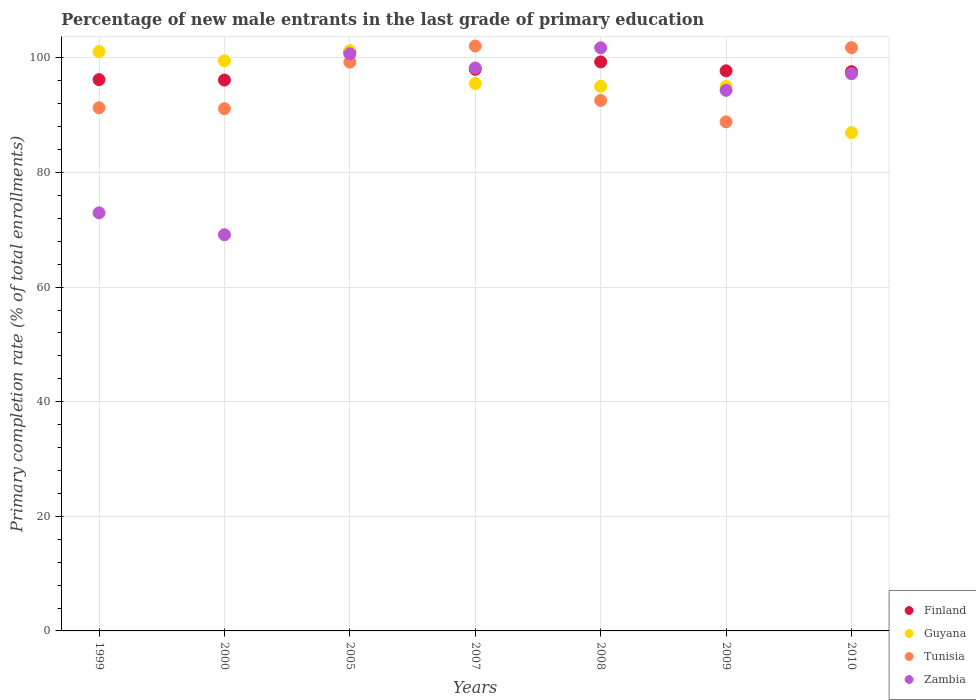How many different coloured dotlines are there?
Offer a terse response. 4. Is the number of dotlines equal to the number of legend labels?
Ensure brevity in your answer.  Yes. What is the percentage of new male entrants in Tunisia in 2009?
Your answer should be very brief. 88.84. Across all years, what is the maximum percentage of new male entrants in Guyana?
Your response must be concise. 101.26. Across all years, what is the minimum percentage of new male entrants in Tunisia?
Offer a very short reply. 88.84. In which year was the percentage of new male entrants in Finland minimum?
Your response must be concise. 2000. What is the total percentage of new male entrants in Finland in the graph?
Give a very brief answer. 686.06. What is the difference between the percentage of new male entrants in Guyana in 2007 and that in 2009?
Your response must be concise. 0.51. What is the difference between the percentage of new male entrants in Guyana in 2009 and the percentage of new male entrants in Zambia in 2010?
Ensure brevity in your answer.  -2.21. What is the average percentage of new male entrants in Zambia per year?
Give a very brief answer. 90.63. In the year 2009, what is the difference between the percentage of new male entrants in Zambia and percentage of new male entrants in Guyana?
Provide a succinct answer. -0.68. What is the ratio of the percentage of new male entrants in Finland in 2005 to that in 2007?
Your response must be concise. 1.03. What is the difference between the highest and the second highest percentage of new male entrants in Guyana?
Offer a very short reply. 0.16. What is the difference between the highest and the lowest percentage of new male entrants in Guyana?
Ensure brevity in your answer.  14.32. Is the sum of the percentage of new male entrants in Zambia in 2007 and 2008 greater than the maximum percentage of new male entrants in Finland across all years?
Provide a short and direct response. Yes. Is it the case that in every year, the sum of the percentage of new male entrants in Zambia and percentage of new male entrants in Guyana  is greater than the percentage of new male entrants in Tunisia?
Offer a very short reply. Yes. Does the percentage of new male entrants in Finland monotonically increase over the years?
Your answer should be very brief. No. Is the percentage of new male entrants in Finland strictly less than the percentage of new male entrants in Zambia over the years?
Give a very brief answer. No. How many dotlines are there?
Make the answer very short. 4. Does the graph contain any zero values?
Provide a succinct answer. No. Where does the legend appear in the graph?
Ensure brevity in your answer.  Bottom right. How are the legend labels stacked?
Offer a very short reply. Vertical. What is the title of the graph?
Ensure brevity in your answer.  Percentage of new male entrants in the last grade of primary education. What is the label or title of the Y-axis?
Offer a very short reply. Primary completion rate (% of total enrollments). What is the Primary completion rate (% of total enrollments) in Finland in 1999?
Ensure brevity in your answer.  96.22. What is the Primary completion rate (% of total enrollments) of Guyana in 1999?
Ensure brevity in your answer.  101.1. What is the Primary completion rate (% of total enrollments) of Tunisia in 1999?
Keep it short and to the point. 91.3. What is the Primary completion rate (% of total enrollments) of Zambia in 1999?
Give a very brief answer. 72.97. What is the Primary completion rate (% of total enrollments) of Finland in 2000?
Offer a terse response. 96.14. What is the Primary completion rate (% of total enrollments) of Guyana in 2000?
Ensure brevity in your answer.  99.5. What is the Primary completion rate (% of total enrollments) in Tunisia in 2000?
Provide a short and direct response. 91.14. What is the Primary completion rate (% of total enrollments) in Zambia in 2000?
Your answer should be very brief. 69.14. What is the Primary completion rate (% of total enrollments) in Finland in 2005?
Make the answer very short. 101.02. What is the Primary completion rate (% of total enrollments) in Guyana in 2005?
Your answer should be compact. 101.26. What is the Primary completion rate (% of total enrollments) in Tunisia in 2005?
Give a very brief answer. 99.27. What is the Primary completion rate (% of total enrollments) in Zambia in 2005?
Offer a very short reply. 100.72. What is the Primary completion rate (% of total enrollments) in Finland in 2007?
Make the answer very short. 98.02. What is the Primary completion rate (% of total enrollments) in Guyana in 2007?
Provide a short and direct response. 95.54. What is the Primary completion rate (% of total enrollments) in Tunisia in 2007?
Offer a very short reply. 102.08. What is the Primary completion rate (% of total enrollments) of Zambia in 2007?
Give a very brief answer. 98.25. What is the Primary completion rate (% of total enrollments) in Finland in 2008?
Keep it short and to the point. 99.31. What is the Primary completion rate (% of total enrollments) in Guyana in 2008?
Provide a succinct answer. 95.04. What is the Primary completion rate (% of total enrollments) in Tunisia in 2008?
Your answer should be very brief. 92.57. What is the Primary completion rate (% of total enrollments) of Zambia in 2008?
Make the answer very short. 101.77. What is the Primary completion rate (% of total enrollments) of Finland in 2009?
Your answer should be very brief. 97.75. What is the Primary completion rate (% of total enrollments) of Guyana in 2009?
Your answer should be compact. 95.03. What is the Primary completion rate (% of total enrollments) in Tunisia in 2009?
Provide a short and direct response. 88.84. What is the Primary completion rate (% of total enrollments) in Zambia in 2009?
Your response must be concise. 94.35. What is the Primary completion rate (% of total enrollments) in Finland in 2010?
Provide a short and direct response. 97.61. What is the Primary completion rate (% of total enrollments) of Guyana in 2010?
Give a very brief answer. 86.94. What is the Primary completion rate (% of total enrollments) in Tunisia in 2010?
Your answer should be compact. 101.79. What is the Primary completion rate (% of total enrollments) in Zambia in 2010?
Make the answer very short. 97.24. Across all years, what is the maximum Primary completion rate (% of total enrollments) of Finland?
Ensure brevity in your answer.  101.02. Across all years, what is the maximum Primary completion rate (% of total enrollments) of Guyana?
Make the answer very short. 101.26. Across all years, what is the maximum Primary completion rate (% of total enrollments) of Tunisia?
Offer a very short reply. 102.08. Across all years, what is the maximum Primary completion rate (% of total enrollments) of Zambia?
Give a very brief answer. 101.77. Across all years, what is the minimum Primary completion rate (% of total enrollments) of Finland?
Your response must be concise. 96.14. Across all years, what is the minimum Primary completion rate (% of total enrollments) in Guyana?
Ensure brevity in your answer.  86.94. Across all years, what is the minimum Primary completion rate (% of total enrollments) in Tunisia?
Keep it short and to the point. 88.84. Across all years, what is the minimum Primary completion rate (% of total enrollments) in Zambia?
Offer a very short reply. 69.14. What is the total Primary completion rate (% of total enrollments) of Finland in the graph?
Give a very brief answer. 686.06. What is the total Primary completion rate (% of total enrollments) of Guyana in the graph?
Provide a short and direct response. 674.42. What is the total Primary completion rate (% of total enrollments) of Tunisia in the graph?
Keep it short and to the point. 667. What is the total Primary completion rate (% of total enrollments) in Zambia in the graph?
Make the answer very short. 634.44. What is the difference between the Primary completion rate (% of total enrollments) in Finland in 1999 and that in 2000?
Make the answer very short. 0.07. What is the difference between the Primary completion rate (% of total enrollments) in Guyana in 1999 and that in 2000?
Your answer should be compact. 1.6. What is the difference between the Primary completion rate (% of total enrollments) of Tunisia in 1999 and that in 2000?
Make the answer very short. 0.16. What is the difference between the Primary completion rate (% of total enrollments) in Zambia in 1999 and that in 2000?
Your response must be concise. 3.82. What is the difference between the Primary completion rate (% of total enrollments) of Finland in 1999 and that in 2005?
Your answer should be very brief. -4.8. What is the difference between the Primary completion rate (% of total enrollments) of Guyana in 1999 and that in 2005?
Offer a very short reply. -0.16. What is the difference between the Primary completion rate (% of total enrollments) of Tunisia in 1999 and that in 2005?
Provide a short and direct response. -7.96. What is the difference between the Primary completion rate (% of total enrollments) of Zambia in 1999 and that in 2005?
Give a very brief answer. -27.76. What is the difference between the Primary completion rate (% of total enrollments) in Finland in 1999 and that in 2007?
Provide a short and direct response. -1.8. What is the difference between the Primary completion rate (% of total enrollments) in Guyana in 1999 and that in 2007?
Offer a terse response. 5.56. What is the difference between the Primary completion rate (% of total enrollments) in Tunisia in 1999 and that in 2007?
Provide a succinct answer. -10.78. What is the difference between the Primary completion rate (% of total enrollments) of Zambia in 1999 and that in 2007?
Offer a very short reply. -25.29. What is the difference between the Primary completion rate (% of total enrollments) of Finland in 1999 and that in 2008?
Offer a terse response. -3.09. What is the difference between the Primary completion rate (% of total enrollments) of Guyana in 1999 and that in 2008?
Ensure brevity in your answer.  6.06. What is the difference between the Primary completion rate (% of total enrollments) of Tunisia in 1999 and that in 2008?
Keep it short and to the point. -1.27. What is the difference between the Primary completion rate (% of total enrollments) in Zambia in 1999 and that in 2008?
Provide a short and direct response. -28.8. What is the difference between the Primary completion rate (% of total enrollments) of Finland in 1999 and that in 2009?
Provide a succinct answer. -1.54. What is the difference between the Primary completion rate (% of total enrollments) in Guyana in 1999 and that in 2009?
Ensure brevity in your answer.  6.07. What is the difference between the Primary completion rate (% of total enrollments) in Tunisia in 1999 and that in 2009?
Provide a succinct answer. 2.46. What is the difference between the Primary completion rate (% of total enrollments) of Zambia in 1999 and that in 2009?
Ensure brevity in your answer.  -21.38. What is the difference between the Primary completion rate (% of total enrollments) of Finland in 1999 and that in 2010?
Provide a succinct answer. -1.39. What is the difference between the Primary completion rate (% of total enrollments) of Guyana in 1999 and that in 2010?
Keep it short and to the point. 14.16. What is the difference between the Primary completion rate (% of total enrollments) in Tunisia in 1999 and that in 2010?
Offer a very short reply. -10.49. What is the difference between the Primary completion rate (% of total enrollments) of Zambia in 1999 and that in 2010?
Your response must be concise. -24.27. What is the difference between the Primary completion rate (% of total enrollments) in Finland in 2000 and that in 2005?
Your response must be concise. -4.88. What is the difference between the Primary completion rate (% of total enrollments) in Guyana in 2000 and that in 2005?
Offer a very short reply. -1.76. What is the difference between the Primary completion rate (% of total enrollments) of Tunisia in 2000 and that in 2005?
Make the answer very short. -8.13. What is the difference between the Primary completion rate (% of total enrollments) of Zambia in 2000 and that in 2005?
Keep it short and to the point. -31.58. What is the difference between the Primary completion rate (% of total enrollments) of Finland in 2000 and that in 2007?
Make the answer very short. -1.88. What is the difference between the Primary completion rate (% of total enrollments) of Guyana in 2000 and that in 2007?
Offer a very short reply. 3.96. What is the difference between the Primary completion rate (% of total enrollments) in Tunisia in 2000 and that in 2007?
Your response must be concise. -10.94. What is the difference between the Primary completion rate (% of total enrollments) in Zambia in 2000 and that in 2007?
Your answer should be compact. -29.11. What is the difference between the Primary completion rate (% of total enrollments) in Finland in 2000 and that in 2008?
Give a very brief answer. -3.16. What is the difference between the Primary completion rate (% of total enrollments) of Guyana in 2000 and that in 2008?
Offer a very short reply. 4.46. What is the difference between the Primary completion rate (% of total enrollments) of Tunisia in 2000 and that in 2008?
Provide a short and direct response. -1.43. What is the difference between the Primary completion rate (% of total enrollments) of Zambia in 2000 and that in 2008?
Make the answer very short. -32.63. What is the difference between the Primary completion rate (% of total enrollments) in Finland in 2000 and that in 2009?
Give a very brief answer. -1.61. What is the difference between the Primary completion rate (% of total enrollments) of Guyana in 2000 and that in 2009?
Your response must be concise. 4.47. What is the difference between the Primary completion rate (% of total enrollments) in Tunisia in 2000 and that in 2009?
Offer a very short reply. 2.29. What is the difference between the Primary completion rate (% of total enrollments) of Zambia in 2000 and that in 2009?
Offer a terse response. -25.21. What is the difference between the Primary completion rate (% of total enrollments) of Finland in 2000 and that in 2010?
Provide a succinct answer. -1.47. What is the difference between the Primary completion rate (% of total enrollments) of Guyana in 2000 and that in 2010?
Keep it short and to the point. 12.55. What is the difference between the Primary completion rate (% of total enrollments) of Tunisia in 2000 and that in 2010?
Make the answer very short. -10.65. What is the difference between the Primary completion rate (% of total enrollments) of Zambia in 2000 and that in 2010?
Your response must be concise. -28.1. What is the difference between the Primary completion rate (% of total enrollments) in Finland in 2005 and that in 2007?
Make the answer very short. 3. What is the difference between the Primary completion rate (% of total enrollments) in Guyana in 2005 and that in 2007?
Keep it short and to the point. 5.72. What is the difference between the Primary completion rate (% of total enrollments) of Tunisia in 2005 and that in 2007?
Your response must be concise. -2.82. What is the difference between the Primary completion rate (% of total enrollments) of Zambia in 2005 and that in 2007?
Offer a terse response. 2.47. What is the difference between the Primary completion rate (% of total enrollments) in Finland in 2005 and that in 2008?
Your response must be concise. 1.71. What is the difference between the Primary completion rate (% of total enrollments) in Guyana in 2005 and that in 2008?
Provide a short and direct response. 6.22. What is the difference between the Primary completion rate (% of total enrollments) of Tunisia in 2005 and that in 2008?
Offer a terse response. 6.69. What is the difference between the Primary completion rate (% of total enrollments) of Zambia in 2005 and that in 2008?
Your answer should be compact. -1.05. What is the difference between the Primary completion rate (% of total enrollments) in Finland in 2005 and that in 2009?
Give a very brief answer. 3.26. What is the difference between the Primary completion rate (% of total enrollments) in Guyana in 2005 and that in 2009?
Your answer should be compact. 6.23. What is the difference between the Primary completion rate (% of total enrollments) of Tunisia in 2005 and that in 2009?
Give a very brief answer. 10.42. What is the difference between the Primary completion rate (% of total enrollments) in Zambia in 2005 and that in 2009?
Offer a terse response. 6.38. What is the difference between the Primary completion rate (% of total enrollments) of Finland in 2005 and that in 2010?
Your answer should be very brief. 3.41. What is the difference between the Primary completion rate (% of total enrollments) in Guyana in 2005 and that in 2010?
Give a very brief answer. 14.32. What is the difference between the Primary completion rate (% of total enrollments) of Tunisia in 2005 and that in 2010?
Give a very brief answer. -2.52. What is the difference between the Primary completion rate (% of total enrollments) of Zambia in 2005 and that in 2010?
Make the answer very short. 3.48. What is the difference between the Primary completion rate (% of total enrollments) of Finland in 2007 and that in 2008?
Offer a terse response. -1.29. What is the difference between the Primary completion rate (% of total enrollments) in Guyana in 2007 and that in 2008?
Provide a succinct answer. 0.5. What is the difference between the Primary completion rate (% of total enrollments) in Tunisia in 2007 and that in 2008?
Offer a terse response. 9.51. What is the difference between the Primary completion rate (% of total enrollments) of Zambia in 2007 and that in 2008?
Provide a short and direct response. -3.52. What is the difference between the Primary completion rate (% of total enrollments) of Finland in 2007 and that in 2009?
Offer a terse response. 0.26. What is the difference between the Primary completion rate (% of total enrollments) in Guyana in 2007 and that in 2009?
Provide a short and direct response. 0.51. What is the difference between the Primary completion rate (% of total enrollments) of Tunisia in 2007 and that in 2009?
Provide a succinct answer. 13.24. What is the difference between the Primary completion rate (% of total enrollments) in Zambia in 2007 and that in 2009?
Make the answer very short. 3.91. What is the difference between the Primary completion rate (% of total enrollments) in Finland in 2007 and that in 2010?
Provide a short and direct response. 0.41. What is the difference between the Primary completion rate (% of total enrollments) of Guyana in 2007 and that in 2010?
Your answer should be very brief. 8.59. What is the difference between the Primary completion rate (% of total enrollments) in Tunisia in 2007 and that in 2010?
Provide a short and direct response. 0.29. What is the difference between the Primary completion rate (% of total enrollments) in Zambia in 2007 and that in 2010?
Your answer should be very brief. 1.01. What is the difference between the Primary completion rate (% of total enrollments) of Finland in 2008 and that in 2009?
Give a very brief answer. 1.55. What is the difference between the Primary completion rate (% of total enrollments) in Guyana in 2008 and that in 2009?
Ensure brevity in your answer.  0.01. What is the difference between the Primary completion rate (% of total enrollments) in Tunisia in 2008 and that in 2009?
Offer a terse response. 3.73. What is the difference between the Primary completion rate (% of total enrollments) in Zambia in 2008 and that in 2009?
Make the answer very short. 7.42. What is the difference between the Primary completion rate (% of total enrollments) in Finland in 2008 and that in 2010?
Provide a succinct answer. 1.7. What is the difference between the Primary completion rate (% of total enrollments) of Guyana in 2008 and that in 2010?
Your response must be concise. 8.1. What is the difference between the Primary completion rate (% of total enrollments) in Tunisia in 2008 and that in 2010?
Your answer should be compact. -9.22. What is the difference between the Primary completion rate (% of total enrollments) in Zambia in 2008 and that in 2010?
Offer a terse response. 4.53. What is the difference between the Primary completion rate (% of total enrollments) in Finland in 2009 and that in 2010?
Provide a short and direct response. 0.14. What is the difference between the Primary completion rate (% of total enrollments) in Guyana in 2009 and that in 2010?
Ensure brevity in your answer.  8.09. What is the difference between the Primary completion rate (% of total enrollments) in Tunisia in 2009 and that in 2010?
Your response must be concise. -12.95. What is the difference between the Primary completion rate (% of total enrollments) of Zambia in 2009 and that in 2010?
Provide a succinct answer. -2.89. What is the difference between the Primary completion rate (% of total enrollments) in Finland in 1999 and the Primary completion rate (% of total enrollments) in Guyana in 2000?
Offer a terse response. -3.28. What is the difference between the Primary completion rate (% of total enrollments) in Finland in 1999 and the Primary completion rate (% of total enrollments) in Tunisia in 2000?
Your response must be concise. 5.08. What is the difference between the Primary completion rate (% of total enrollments) of Finland in 1999 and the Primary completion rate (% of total enrollments) of Zambia in 2000?
Provide a succinct answer. 27.07. What is the difference between the Primary completion rate (% of total enrollments) in Guyana in 1999 and the Primary completion rate (% of total enrollments) in Tunisia in 2000?
Your response must be concise. 9.96. What is the difference between the Primary completion rate (% of total enrollments) in Guyana in 1999 and the Primary completion rate (% of total enrollments) in Zambia in 2000?
Keep it short and to the point. 31.96. What is the difference between the Primary completion rate (% of total enrollments) in Tunisia in 1999 and the Primary completion rate (% of total enrollments) in Zambia in 2000?
Your answer should be compact. 22.16. What is the difference between the Primary completion rate (% of total enrollments) of Finland in 1999 and the Primary completion rate (% of total enrollments) of Guyana in 2005?
Your answer should be compact. -5.05. What is the difference between the Primary completion rate (% of total enrollments) in Finland in 1999 and the Primary completion rate (% of total enrollments) in Tunisia in 2005?
Keep it short and to the point. -3.05. What is the difference between the Primary completion rate (% of total enrollments) of Finland in 1999 and the Primary completion rate (% of total enrollments) of Zambia in 2005?
Your answer should be very brief. -4.51. What is the difference between the Primary completion rate (% of total enrollments) of Guyana in 1999 and the Primary completion rate (% of total enrollments) of Tunisia in 2005?
Provide a succinct answer. 1.84. What is the difference between the Primary completion rate (% of total enrollments) of Guyana in 1999 and the Primary completion rate (% of total enrollments) of Zambia in 2005?
Offer a very short reply. 0.38. What is the difference between the Primary completion rate (% of total enrollments) in Tunisia in 1999 and the Primary completion rate (% of total enrollments) in Zambia in 2005?
Make the answer very short. -9.42. What is the difference between the Primary completion rate (% of total enrollments) in Finland in 1999 and the Primary completion rate (% of total enrollments) in Guyana in 2007?
Your response must be concise. 0.68. What is the difference between the Primary completion rate (% of total enrollments) of Finland in 1999 and the Primary completion rate (% of total enrollments) of Tunisia in 2007?
Keep it short and to the point. -5.87. What is the difference between the Primary completion rate (% of total enrollments) in Finland in 1999 and the Primary completion rate (% of total enrollments) in Zambia in 2007?
Your answer should be compact. -2.04. What is the difference between the Primary completion rate (% of total enrollments) of Guyana in 1999 and the Primary completion rate (% of total enrollments) of Tunisia in 2007?
Your answer should be very brief. -0.98. What is the difference between the Primary completion rate (% of total enrollments) in Guyana in 1999 and the Primary completion rate (% of total enrollments) in Zambia in 2007?
Keep it short and to the point. 2.85. What is the difference between the Primary completion rate (% of total enrollments) of Tunisia in 1999 and the Primary completion rate (% of total enrollments) of Zambia in 2007?
Your response must be concise. -6.95. What is the difference between the Primary completion rate (% of total enrollments) in Finland in 1999 and the Primary completion rate (% of total enrollments) in Guyana in 2008?
Offer a very short reply. 1.18. What is the difference between the Primary completion rate (% of total enrollments) of Finland in 1999 and the Primary completion rate (% of total enrollments) of Tunisia in 2008?
Your answer should be very brief. 3.64. What is the difference between the Primary completion rate (% of total enrollments) in Finland in 1999 and the Primary completion rate (% of total enrollments) in Zambia in 2008?
Your answer should be very brief. -5.55. What is the difference between the Primary completion rate (% of total enrollments) in Guyana in 1999 and the Primary completion rate (% of total enrollments) in Tunisia in 2008?
Provide a short and direct response. 8.53. What is the difference between the Primary completion rate (% of total enrollments) of Guyana in 1999 and the Primary completion rate (% of total enrollments) of Zambia in 2008?
Your response must be concise. -0.67. What is the difference between the Primary completion rate (% of total enrollments) of Tunisia in 1999 and the Primary completion rate (% of total enrollments) of Zambia in 2008?
Provide a short and direct response. -10.47. What is the difference between the Primary completion rate (% of total enrollments) in Finland in 1999 and the Primary completion rate (% of total enrollments) in Guyana in 2009?
Make the answer very short. 1.18. What is the difference between the Primary completion rate (% of total enrollments) in Finland in 1999 and the Primary completion rate (% of total enrollments) in Tunisia in 2009?
Your answer should be compact. 7.37. What is the difference between the Primary completion rate (% of total enrollments) in Finland in 1999 and the Primary completion rate (% of total enrollments) in Zambia in 2009?
Your response must be concise. 1.87. What is the difference between the Primary completion rate (% of total enrollments) in Guyana in 1999 and the Primary completion rate (% of total enrollments) in Tunisia in 2009?
Offer a very short reply. 12.26. What is the difference between the Primary completion rate (% of total enrollments) in Guyana in 1999 and the Primary completion rate (% of total enrollments) in Zambia in 2009?
Ensure brevity in your answer.  6.75. What is the difference between the Primary completion rate (% of total enrollments) of Tunisia in 1999 and the Primary completion rate (% of total enrollments) of Zambia in 2009?
Provide a short and direct response. -3.05. What is the difference between the Primary completion rate (% of total enrollments) of Finland in 1999 and the Primary completion rate (% of total enrollments) of Guyana in 2010?
Offer a very short reply. 9.27. What is the difference between the Primary completion rate (% of total enrollments) in Finland in 1999 and the Primary completion rate (% of total enrollments) in Tunisia in 2010?
Keep it short and to the point. -5.58. What is the difference between the Primary completion rate (% of total enrollments) in Finland in 1999 and the Primary completion rate (% of total enrollments) in Zambia in 2010?
Your response must be concise. -1.02. What is the difference between the Primary completion rate (% of total enrollments) of Guyana in 1999 and the Primary completion rate (% of total enrollments) of Tunisia in 2010?
Keep it short and to the point. -0.69. What is the difference between the Primary completion rate (% of total enrollments) of Guyana in 1999 and the Primary completion rate (% of total enrollments) of Zambia in 2010?
Give a very brief answer. 3.86. What is the difference between the Primary completion rate (% of total enrollments) in Tunisia in 1999 and the Primary completion rate (% of total enrollments) in Zambia in 2010?
Provide a succinct answer. -5.94. What is the difference between the Primary completion rate (% of total enrollments) of Finland in 2000 and the Primary completion rate (% of total enrollments) of Guyana in 2005?
Offer a terse response. -5.12. What is the difference between the Primary completion rate (% of total enrollments) of Finland in 2000 and the Primary completion rate (% of total enrollments) of Tunisia in 2005?
Your answer should be compact. -3.13. What is the difference between the Primary completion rate (% of total enrollments) of Finland in 2000 and the Primary completion rate (% of total enrollments) of Zambia in 2005?
Offer a terse response. -4.58. What is the difference between the Primary completion rate (% of total enrollments) of Guyana in 2000 and the Primary completion rate (% of total enrollments) of Tunisia in 2005?
Your response must be concise. 0.23. What is the difference between the Primary completion rate (% of total enrollments) of Guyana in 2000 and the Primary completion rate (% of total enrollments) of Zambia in 2005?
Your answer should be very brief. -1.23. What is the difference between the Primary completion rate (% of total enrollments) of Tunisia in 2000 and the Primary completion rate (% of total enrollments) of Zambia in 2005?
Provide a succinct answer. -9.58. What is the difference between the Primary completion rate (% of total enrollments) in Finland in 2000 and the Primary completion rate (% of total enrollments) in Guyana in 2007?
Make the answer very short. 0.6. What is the difference between the Primary completion rate (% of total enrollments) of Finland in 2000 and the Primary completion rate (% of total enrollments) of Tunisia in 2007?
Your answer should be compact. -5.94. What is the difference between the Primary completion rate (% of total enrollments) in Finland in 2000 and the Primary completion rate (% of total enrollments) in Zambia in 2007?
Give a very brief answer. -2.11. What is the difference between the Primary completion rate (% of total enrollments) in Guyana in 2000 and the Primary completion rate (% of total enrollments) in Tunisia in 2007?
Your response must be concise. -2.58. What is the difference between the Primary completion rate (% of total enrollments) in Guyana in 2000 and the Primary completion rate (% of total enrollments) in Zambia in 2007?
Provide a succinct answer. 1.24. What is the difference between the Primary completion rate (% of total enrollments) in Tunisia in 2000 and the Primary completion rate (% of total enrollments) in Zambia in 2007?
Give a very brief answer. -7.11. What is the difference between the Primary completion rate (% of total enrollments) in Finland in 2000 and the Primary completion rate (% of total enrollments) in Guyana in 2008?
Give a very brief answer. 1.1. What is the difference between the Primary completion rate (% of total enrollments) of Finland in 2000 and the Primary completion rate (% of total enrollments) of Tunisia in 2008?
Provide a short and direct response. 3.57. What is the difference between the Primary completion rate (% of total enrollments) of Finland in 2000 and the Primary completion rate (% of total enrollments) of Zambia in 2008?
Provide a short and direct response. -5.63. What is the difference between the Primary completion rate (% of total enrollments) of Guyana in 2000 and the Primary completion rate (% of total enrollments) of Tunisia in 2008?
Your answer should be very brief. 6.92. What is the difference between the Primary completion rate (% of total enrollments) of Guyana in 2000 and the Primary completion rate (% of total enrollments) of Zambia in 2008?
Your answer should be very brief. -2.27. What is the difference between the Primary completion rate (% of total enrollments) in Tunisia in 2000 and the Primary completion rate (% of total enrollments) in Zambia in 2008?
Offer a terse response. -10.63. What is the difference between the Primary completion rate (% of total enrollments) of Finland in 2000 and the Primary completion rate (% of total enrollments) of Guyana in 2009?
Make the answer very short. 1.11. What is the difference between the Primary completion rate (% of total enrollments) of Finland in 2000 and the Primary completion rate (% of total enrollments) of Tunisia in 2009?
Make the answer very short. 7.3. What is the difference between the Primary completion rate (% of total enrollments) of Finland in 2000 and the Primary completion rate (% of total enrollments) of Zambia in 2009?
Make the answer very short. 1.79. What is the difference between the Primary completion rate (% of total enrollments) of Guyana in 2000 and the Primary completion rate (% of total enrollments) of Tunisia in 2009?
Offer a very short reply. 10.65. What is the difference between the Primary completion rate (% of total enrollments) of Guyana in 2000 and the Primary completion rate (% of total enrollments) of Zambia in 2009?
Keep it short and to the point. 5.15. What is the difference between the Primary completion rate (% of total enrollments) in Tunisia in 2000 and the Primary completion rate (% of total enrollments) in Zambia in 2009?
Your answer should be compact. -3.21. What is the difference between the Primary completion rate (% of total enrollments) of Finland in 2000 and the Primary completion rate (% of total enrollments) of Guyana in 2010?
Keep it short and to the point. 9.2. What is the difference between the Primary completion rate (% of total enrollments) in Finland in 2000 and the Primary completion rate (% of total enrollments) in Tunisia in 2010?
Make the answer very short. -5.65. What is the difference between the Primary completion rate (% of total enrollments) of Finland in 2000 and the Primary completion rate (% of total enrollments) of Zambia in 2010?
Keep it short and to the point. -1.1. What is the difference between the Primary completion rate (% of total enrollments) of Guyana in 2000 and the Primary completion rate (% of total enrollments) of Tunisia in 2010?
Your answer should be compact. -2.29. What is the difference between the Primary completion rate (% of total enrollments) in Guyana in 2000 and the Primary completion rate (% of total enrollments) in Zambia in 2010?
Keep it short and to the point. 2.26. What is the difference between the Primary completion rate (% of total enrollments) in Tunisia in 2000 and the Primary completion rate (% of total enrollments) in Zambia in 2010?
Offer a very short reply. -6.1. What is the difference between the Primary completion rate (% of total enrollments) of Finland in 2005 and the Primary completion rate (% of total enrollments) of Guyana in 2007?
Your answer should be compact. 5.48. What is the difference between the Primary completion rate (% of total enrollments) in Finland in 2005 and the Primary completion rate (% of total enrollments) in Tunisia in 2007?
Your answer should be very brief. -1.07. What is the difference between the Primary completion rate (% of total enrollments) in Finland in 2005 and the Primary completion rate (% of total enrollments) in Zambia in 2007?
Offer a terse response. 2.76. What is the difference between the Primary completion rate (% of total enrollments) in Guyana in 2005 and the Primary completion rate (% of total enrollments) in Tunisia in 2007?
Your answer should be very brief. -0.82. What is the difference between the Primary completion rate (% of total enrollments) of Guyana in 2005 and the Primary completion rate (% of total enrollments) of Zambia in 2007?
Offer a very short reply. 3.01. What is the difference between the Primary completion rate (% of total enrollments) of Tunisia in 2005 and the Primary completion rate (% of total enrollments) of Zambia in 2007?
Your response must be concise. 1.01. What is the difference between the Primary completion rate (% of total enrollments) of Finland in 2005 and the Primary completion rate (% of total enrollments) of Guyana in 2008?
Keep it short and to the point. 5.98. What is the difference between the Primary completion rate (% of total enrollments) in Finland in 2005 and the Primary completion rate (% of total enrollments) in Tunisia in 2008?
Offer a terse response. 8.44. What is the difference between the Primary completion rate (% of total enrollments) of Finland in 2005 and the Primary completion rate (% of total enrollments) of Zambia in 2008?
Provide a short and direct response. -0.75. What is the difference between the Primary completion rate (% of total enrollments) of Guyana in 2005 and the Primary completion rate (% of total enrollments) of Tunisia in 2008?
Your response must be concise. 8.69. What is the difference between the Primary completion rate (% of total enrollments) of Guyana in 2005 and the Primary completion rate (% of total enrollments) of Zambia in 2008?
Offer a very short reply. -0.51. What is the difference between the Primary completion rate (% of total enrollments) of Tunisia in 2005 and the Primary completion rate (% of total enrollments) of Zambia in 2008?
Keep it short and to the point. -2.5. What is the difference between the Primary completion rate (% of total enrollments) of Finland in 2005 and the Primary completion rate (% of total enrollments) of Guyana in 2009?
Offer a terse response. 5.98. What is the difference between the Primary completion rate (% of total enrollments) of Finland in 2005 and the Primary completion rate (% of total enrollments) of Tunisia in 2009?
Make the answer very short. 12.17. What is the difference between the Primary completion rate (% of total enrollments) of Finland in 2005 and the Primary completion rate (% of total enrollments) of Zambia in 2009?
Your answer should be very brief. 6.67. What is the difference between the Primary completion rate (% of total enrollments) of Guyana in 2005 and the Primary completion rate (% of total enrollments) of Tunisia in 2009?
Your response must be concise. 12.42. What is the difference between the Primary completion rate (% of total enrollments) of Guyana in 2005 and the Primary completion rate (% of total enrollments) of Zambia in 2009?
Offer a very short reply. 6.91. What is the difference between the Primary completion rate (% of total enrollments) of Tunisia in 2005 and the Primary completion rate (% of total enrollments) of Zambia in 2009?
Your response must be concise. 4.92. What is the difference between the Primary completion rate (% of total enrollments) in Finland in 2005 and the Primary completion rate (% of total enrollments) in Guyana in 2010?
Ensure brevity in your answer.  14.07. What is the difference between the Primary completion rate (% of total enrollments) of Finland in 2005 and the Primary completion rate (% of total enrollments) of Tunisia in 2010?
Provide a succinct answer. -0.77. What is the difference between the Primary completion rate (% of total enrollments) of Finland in 2005 and the Primary completion rate (% of total enrollments) of Zambia in 2010?
Your response must be concise. 3.78. What is the difference between the Primary completion rate (% of total enrollments) in Guyana in 2005 and the Primary completion rate (% of total enrollments) in Tunisia in 2010?
Offer a terse response. -0.53. What is the difference between the Primary completion rate (% of total enrollments) in Guyana in 2005 and the Primary completion rate (% of total enrollments) in Zambia in 2010?
Your answer should be compact. 4.02. What is the difference between the Primary completion rate (% of total enrollments) of Tunisia in 2005 and the Primary completion rate (% of total enrollments) of Zambia in 2010?
Give a very brief answer. 2.03. What is the difference between the Primary completion rate (% of total enrollments) in Finland in 2007 and the Primary completion rate (% of total enrollments) in Guyana in 2008?
Provide a short and direct response. 2.98. What is the difference between the Primary completion rate (% of total enrollments) in Finland in 2007 and the Primary completion rate (% of total enrollments) in Tunisia in 2008?
Your response must be concise. 5.44. What is the difference between the Primary completion rate (% of total enrollments) of Finland in 2007 and the Primary completion rate (% of total enrollments) of Zambia in 2008?
Offer a very short reply. -3.75. What is the difference between the Primary completion rate (% of total enrollments) of Guyana in 2007 and the Primary completion rate (% of total enrollments) of Tunisia in 2008?
Provide a short and direct response. 2.96. What is the difference between the Primary completion rate (% of total enrollments) of Guyana in 2007 and the Primary completion rate (% of total enrollments) of Zambia in 2008?
Your answer should be compact. -6.23. What is the difference between the Primary completion rate (% of total enrollments) in Tunisia in 2007 and the Primary completion rate (% of total enrollments) in Zambia in 2008?
Offer a very short reply. 0.31. What is the difference between the Primary completion rate (% of total enrollments) of Finland in 2007 and the Primary completion rate (% of total enrollments) of Guyana in 2009?
Your answer should be compact. 2.99. What is the difference between the Primary completion rate (% of total enrollments) of Finland in 2007 and the Primary completion rate (% of total enrollments) of Tunisia in 2009?
Keep it short and to the point. 9.17. What is the difference between the Primary completion rate (% of total enrollments) in Finland in 2007 and the Primary completion rate (% of total enrollments) in Zambia in 2009?
Provide a succinct answer. 3.67. What is the difference between the Primary completion rate (% of total enrollments) in Guyana in 2007 and the Primary completion rate (% of total enrollments) in Tunisia in 2009?
Keep it short and to the point. 6.69. What is the difference between the Primary completion rate (% of total enrollments) in Guyana in 2007 and the Primary completion rate (% of total enrollments) in Zambia in 2009?
Give a very brief answer. 1.19. What is the difference between the Primary completion rate (% of total enrollments) in Tunisia in 2007 and the Primary completion rate (% of total enrollments) in Zambia in 2009?
Make the answer very short. 7.73. What is the difference between the Primary completion rate (% of total enrollments) of Finland in 2007 and the Primary completion rate (% of total enrollments) of Guyana in 2010?
Your response must be concise. 11.07. What is the difference between the Primary completion rate (% of total enrollments) in Finland in 2007 and the Primary completion rate (% of total enrollments) in Tunisia in 2010?
Keep it short and to the point. -3.77. What is the difference between the Primary completion rate (% of total enrollments) of Finland in 2007 and the Primary completion rate (% of total enrollments) of Zambia in 2010?
Your response must be concise. 0.78. What is the difference between the Primary completion rate (% of total enrollments) of Guyana in 2007 and the Primary completion rate (% of total enrollments) of Tunisia in 2010?
Offer a very short reply. -6.25. What is the difference between the Primary completion rate (% of total enrollments) in Guyana in 2007 and the Primary completion rate (% of total enrollments) in Zambia in 2010?
Give a very brief answer. -1.7. What is the difference between the Primary completion rate (% of total enrollments) in Tunisia in 2007 and the Primary completion rate (% of total enrollments) in Zambia in 2010?
Make the answer very short. 4.84. What is the difference between the Primary completion rate (% of total enrollments) of Finland in 2008 and the Primary completion rate (% of total enrollments) of Guyana in 2009?
Keep it short and to the point. 4.27. What is the difference between the Primary completion rate (% of total enrollments) of Finland in 2008 and the Primary completion rate (% of total enrollments) of Tunisia in 2009?
Give a very brief answer. 10.46. What is the difference between the Primary completion rate (% of total enrollments) in Finland in 2008 and the Primary completion rate (% of total enrollments) in Zambia in 2009?
Provide a succinct answer. 4.96. What is the difference between the Primary completion rate (% of total enrollments) of Guyana in 2008 and the Primary completion rate (% of total enrollments) of Tunisia in 2009?
Your response must be concise. 6.2. What is the difference between the Primary completion rate (% of total enrollments) in Guyana in 2008 and the Primary completion rate (% of total enrollments) in Zambia in 2009?
Provide a succinct answer. 0.69. What is the difference between the Primary completion rate (% of total enrollments) in Tunisia in 2008 and the Primary completion rate (% of total enrollments) in Zambia in 2009?
Give a very brief answer. -1.77. What is the difference between the Primary completion rate (% of total enrollments) of Finland in 2008 and the Primary completion rate (% of total enrollments) of Guyana in 2010?
Provide a succinct answer. 12.36. What is the difference between the Primary completion rate (% of total enrollments) of Finland in 2008 and the Primary completion rate (% of total enrollments) of Tunisia in 2010?
Make the answer very short. -2.49. What is the difference between the Primary completion rate (% of total enrollments) of Finland in 2008 and the Primary completion rate (% of total enrollments) of Zambia in 2010?
Provide a succinct answer. 2.06. What is the difference between the Primary completion rate (% of total enrollments) in Guyana in 2008 and the Primary completion rate (% of total enrollments) in Tunisia in 2010?
Ensure brevity in your answer.  -6.75. What is the difference between the Primary completion rate (% of total enrollments) in Guyana in 2008 and the Primary completion rate (% of total enrollments) in Zambia in 2010?
Offer a very short reply. -2.2. What is the difference between the Primary completion rate (% of total enrollments) in Tunisia in 2008 and the Primary completion rate (% of total enrollments) in Zambia in 2010?
Give a very brief answer. -4.67. What is the difference between the Primary completion rate (% of total enrollments) of Finland in 2009 and the Primary completion rate (% of total enrollments) of Guyana in 2010?
Offer a terse response. 10.81. What is the difference between the Primary completion rate (% of total enrollments) of Finland in 2009 and the Primary completion rate (% of total enrollments) of Tunisia in 2010?
Provide a short and direct response. -4.04. What is the difference between the Primary completion rate (% of total enrollments) of Finland in 2009 and the Primary completion rate (% of total enrollments) of Zambia in 2010?
Keep it short and to the point. 0.51. What is the difference between the Primary completion rate (% of total enrollments) in Guyana in 2009 and the Primary completion rate (% of total enrollments) in Tunisia in 2010?
Your answer should be compact. -6.76. What is the difference between the Primary completion rate (% of total enrollments) of Guyana in 2009 and the Primary completion rate (% of total enrollments) of Zambia in 2010?
Give a very brief answer. -2.21. What is the difference between the Primary completion rate (% of total enrollments) in Tunisia in 2009 and the Primary completion rate (% of total enrollments) in Zambia in 2010?
Ensure brevity in your answer.  -8.4. What is the average Primary completion rate (% of total enrollments) of Finland per year?
Your answer should be compact. 98.01. What is the average Primary completion rate (% of total enrollments) in Guyana per year?
Your response must be concise. 96.35. What is the average Primary completion rate (% of total enrollments) in Tunisia per year?
Your response must be concise. 95.29. What is the average Primary completion rate (% of total enrollments) in Zambia per year?
Offer a terse response. 90.63. In the year 1999, what is the difference between the Primary completion rate (% of total enrollments) of Finland and Primary completion rate (% of total enrollments) of Guyana?
Your answer should be compact. -4.89. In the year 1999, what is the difference between the Primary completion rate (% of total enrollments) in Finland and Primary completion rate (% of total enrollments) in Tunisia?
Your answer should be very brief. 4.91. In the year 1999, what is the difference between the Primary completion rate (% of total enrollments) of Finland and Primary completion rate (% of total enrollments) of Zambia?
Offer a very short reply. 23.25. In the year 1999, what is the difference between the Primary completion rate (% of total enrollments) of Guyana and Primary completion rate (% of total enrollments) of Tunisia?
Your response must be concise. 9.8. In the year 1999, what is the difference between the Primary completion rate (% of total enrollments) in Guyana and Primary completion rate (% of total enrollments) in Zambia?
Your response must be concise. 28.14. In the year 1999, what is the difference between the Primary completion rate (% of total enrollments) of Tunisia and Primary completion rate (% of total enrollments) of Zambia?
Keep it short and to the point. 18.34. In the year 2000, what is the difference between the Primary completion rate (% of total enrollments) of Finland and Primary completion rate (% of total enrollments) of Guyana?
Offer a terse response. -3.36. In the year 2000, what is the difference between the Primary completion rate (% of total enrollments) in Finland and Primary completion rate (% of total enrollments) in Tunisia?
Offer a terse response. 5. In the year 2000, what is the difference between the Primary completion rate (% of total enrollments) in Finland and Primary completion rate (% of total enrollments) in Zambia?
Your answer should be very brief. 27. In the year 2000, what is the difference between the Primary completion rate (% of total enrollments) in Guyana and Primary completion rate (% of total enrollments) in Tunisia?
Keep it short and to the point. 8.36. In the year 2000, what is the difference between the Primary completion rate (% of total enrollments) of Guyana and Primary completion rate (% of total enrollments) of Zambia?
Your answer should be compact. 30.35. In the year 2000, what is the difference between the Primary completion rate (% of total enrollments) in Tunisia and Primary completion rate (% of total enrollments) in Zambia?
Your answer should be very brief. 22. In the year 2005, what is the difference between the Primary completion rate (% of total enrollments) in Finland and Primary completion rate (% of total enrollments) in Guyana?
Your answer should be very brief. -0.25. In the year 2005, what is the difference between the Primary completion rate (% of total enrollments) of Finland and Primary completion rate (% of total enrollments) of Tunisia?
Offer a very short reply. 1.75. In the year 2005, what is the difference between the Primary completion rate (% of total enrollments) in Finland and Primary completion rate (% of total enrollments) in Zambia?
Offer a very short reply. 0.29. In the year 2005, what is the difference between the Primary completion rate (% of total enrollments) in Guyana and Primary completion rate (% of total enrollments) in Tunisia?
Your answer should be very brief. 2. In the year 2005, what is the difference between the Primary completion rate (% of total enrollments) in Guyana and Primary completion rate (% of total enrollments) in Zambia?
Your answer should be compact. 0.54. In the year 2005, what is the difference between the Primary completion rate (% of total enrollments) of Tunisia and Primary completion rate (% of total enrollments) of Zambia?
Your response must be concise. -1.46. In the year 2007, what is the difference between the Primary completion rate (% of total enrollments) in Finland and Primary completion rate (% of total enrollments) in Guyana?
Offer a terse response. 2.48. In the year 2007, what is the difference between the Primary completion rate (% of total enrollments) in Finland and Primary completion rate (% of total enrollments) in Tunisia?
Make the answer very short. -4.06. In the year 2007, what is the difference between the Primary completion rate (% of total enrollments) of Finland and Primary completion rate (% of total enrollments) of Zambia?
Make the answer very short. -0.24. In the year 2007, what is the difference between the Primary completion rate (% of total enrollments) in Guyana and Primary completion rate (% of total enrollments) in Tunisia?
Offer a very short reply. -6.54. In the year 2007, what is the difference between the Primary completion rate (% of total enrollments) of Guyana and Primary completion rate (% of total enrollments) of Zambia?
Ensure brevity in your answer.  -2.72. In the year 2007, what is the difference between the Primary completion rate (% of total enrollments) in Tunisia and Primary completion rate (% of total enrollments) in Zambia?
Offer a terse response. 3.83. In the year 2008, what is the difference between the Primary completion rate (% of total enrollments) of Finland and Primary completion rate (% of total enrollments) of Guyana?
Your response must be concise. 4.27. In the year 2008, what is the difference between the Primary completion rate (% of total enrollments) of Finland and Primary completion rate (% of total enrollments) of Tunisia?
Keep it short and to the point. 6.73. In the year 2008, what is the difference between the Primary completion rate (% of total enrollments) in Finland and Primary completion rate (% of total enrollments) in Zambia?
Your answer should be very brief. -2.46. In the year 2008, what is the difference between the Primary completion rate (% of total enrollments) of Guyana and Primary completion rate (% of total enrollments) of Tunisia?
Provide a succinct answer. 2.47. In the year 2008, what is the difference between the Primary completion rate (% of total enrollments) in Guyana and Primary completion rate (% of total enrollments) in Zambia?
Provide a succinct answer. -6.73. In the year 2008, what is the difference between the Primary completion rate (% of total enrollments) in Tunisia and Primary completion rate (% of total enrollments) in Zambia?
Ensure brevity in your answer.  -9.19. In the year 2009, what is the difference between the Primary completion rate (% of total enrollments) of Finland and Primary completion rate (% of total enrollments) of Guyana?
Ensure brevity in your answer.  2.72. In the year 2009, what is the difference between the Primary completion rate (% of total enrollments) of Finland and Primary completion rate (% of total enrollments) of Tunisia?
Ensure brevity in your answer.  8.91. In the year 2009, what is the difference between the Primary completion rate (% of total enrollments) of Finland and Primary completion rate (% of total enrollments) of Zambia?
Keep it short and to the point. 3.41. In the year 2009, what is the difference between the Primary completion rate (% of total enrollments) in Guyana and Primary completion rate (% of total enrollments) in Tunisia?
Your response must be concise. 6.19. In the year 2009, what is the difference between the Primary completion rate (% of total enrollments) in Guyana and Primary completion rate (% of total enrollments) in Zambia?
Provide a succinct answer. 0.68. In the year 2009, what is the difference between the Primary completion rate (% of total enrollments) of Tunisia and Primary completion rate (% of total enrollments) of Zambia?
Ensure brevity in your answer.  -5.5. In the year 2010, what is the difference between the Primary completion rate (% of total enrollments) in Finland and Primary completion rate (% of total enrollments) in Guyana?
Provide a short and direct response. 10.66. In the year 2010, what is the difference between the Primary completion rate (% of total enrollments) of Finland and Primary completion rate (% of total enrollments) of Tunisia?
Offer a very short reply. -4.18. In the year 2010, what is the difference between the Primary completion rate (% of total enrollments) of Finland and Primary completion rate (% of total enrollments) of Zambia?
Give a very brief answer. 0.37. In the year 2010, what is the difference between the Primary completion rate (% of total enrollments) in Guyana and Primary completion rate (% of total enrollments) in Tunisia?
Keep it short and to the point. -14.85. In the year 2010, what is the difference between the Primary completion rate (% of total enrollments) of Guyana and Primary completion rate (% of total enrollments) of Zambia?
Provide a succinct answer. -10.3. In the year 2010, what is the difference between the Primary completion rate (% of total enrollments) of Tunisia and Primary completion rate (% of total enrollments) of Zambia?
Keep it short and to the point. 4.55. What is the ratio of the Primary completion rate (% of total enrollments) in Finland in 1999 to that in 2000?
Your answer should be compact. 1. What is the ratio of the Primary completion rate (% of total enrollments) in Guyana in 1999 to that in 2000?
Offer a very short reply. 1.02. What is the ratio of the Primary completion rate (% of total enrollments) in Zambia in 1999 to that in 2000?
Your answer should be very brief. 1.06. What is the ratio of the Primary completion rate (% of total enrollments) of Finland in 1999 to that in 2005?
Your response must be concise. 0.95. What is the ratio of the Primary completion rate (% of total enrollments) of Tunisia in 1999 to that in 2005?
Your response must be concise. 0.92. What is the ratio of the Primary completion rate (% of total enrollments) in Zambia in 1999 to that in 2005?
Make the answer very short. 0.72. What is the ratio of the Primary completion rate (% of total enrollments) of Finland in 1999 to that in 2007?
Your response must be concise. 0.98. What is the ratio of the Primary completion rate (% of total enrollments) of Guyana in 1999 to that in 2007?
Provide a short and direct response. 1.06. What is the ratio of the Primary completion rate (% of total enrollments) in Tunisia in 1999 to that in 2007?
Your answer should be compact. 0.89. What is the ratio of the Primary completion rate (% of total enrollments) in Zambia in 1999 to that in 2007?
Provide a succinct answer. 0.74. What is the ratio of the Primary completion rate (% of total enrollments) of Finland in 1999 to that in 2008?
Keep it short and to the point. 0.97. What is the ratio of the Primary completion rate (% of total enrollments) in Guyana in 1999 to that in 2008?
Offer a very short reply. 1.06. What is the ratio of the Primary completion rate (% of total enrollments) in Tunisia in 1999 to that in 2008?
Offer a terse response. 0.99. What is the ratio of the Primary completion rate (% of total enrollments) of Zambia in 1999 to that in 2008?
Offer a very short reply. 0.72. What is the ratio of the Primary completion rate (% of total enrollments) in Finland in 1999 to that in 2009?
Give a very brief answer. 0.98. What is the ratio of the Primary completion rate (% of total enrollments) in Guyana in 1999 to that in 2009?
Keep it short and to the point. 1.06. What is the ratio of the Primary completion rate (% of total enrollments) in Tunisia in 1999 to that in 2009?
Provide a short and direct response. 1.03. What is the ratio of the Primary completion rate (% of total enrollments) in Zambia in 1999 to that in 2009?
Keep it short and to the point. 0.77. What is the ratio of the Primary completion rate (% of total enrollments) in Finland in 1999 to that in 2010?
Offer a terse response. 0.99. What is the ratio of the Primary completion rate (% of total enrollments) in Guyana in 1999 to that in 2010?
Your answer should be very brief. 1.16. What is the ratio of the Primary completion rate (% of total enrollments) of Tunisia in 1999 to that in 2010?
Your answer should be compact. 0.9. What is the ratio of the Primary completion rate (% of total enrollments) of Zambia in 1999 to that in 2010?
Keep it short and to the point. 0.75. What is the ratio of the Primary completion rate (% of total enrollments) of Finland in 2000 to that in 2005?
Provide a short and direct response. 0.95. What is the ratio of the Primary completion rate (% of total enrollments) in Guyana in 2000 to that in 2005?
Keep it short and to the point. 0.98. What is the ratio of the Primary completion rate (% of total enrollments) in Tunisia in 2000 to that in 2005?
Ensure brevity in your answer.  0.92. What is the ratio of the Primary completion rate (% of total enrollments) in Zambia in 2000 to that in 2005?
Make the answer very short. 0.69. What is the ratio of the Primary completion rate (% of total enrollments) in Finland in 2000 to that in 2007?
Your answer should be compact. 0.98. What is the ratio of the Primary completion rate (% of total enrollments) of Guyana in 2000 to that in 2007?
Your response must be concise. 1.04. What is the ratio of the Primary completion rate (% of total enrollments) of Tunisia in 2000 to that in 2007?
Offer a very short reply. 0.89. What is the ratio of the Primary completion rate (% of total enrollments) in Zambia in 2000 to that in 2007?
Give a very brief answer. 0.7. What is the ratio of the Primary completion rate (% of total enrollments) in Finland in 2000 to that in 2008?
Offer a terse response. 0.97. What is the ratio of the Primary completion rate (% of total enrollments) of Guyana in 2000 to that in 2008?
Provide a succinct answer. 1.05. What is the ratio of the Primary completion rate (% of total enrollments) in Tunisia in 2000 to that in 2008?
Provide a succinct answer. 0.98. What is the ratio of the Primary completion rate (% of total enrollments) of Zambia in 2000 to that in 2008?
Your answer should be compact. 0.68. What is the ratio of the Primary completion rate (% of total enrollments) in Finland in 2000 to that in 2009?
Provide a short and direct response. 0.98. What is the ratio of the Primary completion rate (% of total enrollments) of Guyana in 2000 to that in 2009?
Your answer should be very brief. 1.05. What is the ratio of the Primary completion rate (% of total enrollments) in Tunisia in 2000 to that in 2009?
Give a very brief answer. 1.03. What is the ratio of the Primary completion rate (% of total enrollments) of Zambia in 2000 to that in 2009?
Your response must be concise. 0.73. What is the ratio of the Primary completion rate (% of total enrollments) in Finland in 2000 to that in 2010?
Keep it short and to the point. 0.98. What is the ratio of the Primary completion rate (% of total enrollments) of Guyana in 2000 to that in 2010?
Provide a short and direct response. 1.14. What is the ratio of the Primary completion rate (% of total enrollments) of Tunisia in 2000 to that in 2010?
Provide a short and direct response. 0.9. What is the ratio of the Primary completion rate (% of total enrollments) in Zambia in 2000 to that in 2010?
Your response must be concise. 0.71. What is the ratio of the Primary completion rate (% of total enrollments) of Finland in 2005 to that in 2007?
Your answer should be very brief. 1.03. What is the ratio of the Primary completion rate (% of total enrollments) of Guyana in 2005 to that in 2007?
Your answer should be very brief. 1.06. What is the ratio of the Primary completion rate (% of total enrollments) in Tunisia in 2005 to that in 2007?
Your answer should be compact. 0.97. What is the ratio of the Primary completion rate (% of total enrollments) of Zambia in 2005 to that in 2007?
Offer a terse response. 1.03. What is the ratio of the Primary completion rate (% of total enrollments) of Finland in 2005 to that in 2008?
Your answer should be compact. 1.02. What is the ratio of the Primary completion rate (% of total enrollments) in Guyana in 2005 to that in 2008?
Provide a succinct answer. 1.07. What is the ratio of the Primary completion rate (% of total enrollments) of Tunisia in 2005 to that in 2008?
Make the answer very short. 1.07. What is the ratio of the Primary completion rate (% of total enrollments) in Finland in 2005 to that in 2009?
Your response must be concise. 1.03. What is the ratio of the Primary completion rate (% of total enrollments) in Guyana in 2005 to that in 2009?
Make the answer very short. 1.07. What is the ratio of the Primary completion rate (% of total enrollments) in Tunisia in 2005 to that in 2009?
Your answer should be very brief. 1.12. What is the ratio of the Primary completion rate (% of total enrollments) in Zambia in 2005 to that in 2009?
Offer a very short reply. 1.07. What is the ratio of the Primary completion rate (% of total enrollments) of Finland in 2005 to that in 2010?
Ensure brevity in your answer.  1.03. What is the ratio of the Primary completion rate (% of total enrollments) in Guyana in 2005 to that in 2010?
Give a very brief answer. 1.16. What is the ratio of the Primary completion rate (% of total enrollments) in Tunisia in 2005 to that in 2010?
Provide a succinct answer. 0.98. What is the ratio of the Primary completion rate (% of total enrollments) of Zambia in 2005 to that in 2010?
Provide a succinct answer. 1.04. What is the ratio of the Primary completion rate (% of total enrollments) in Finland in 2007 to that in 2008?
Your answer should be very brief. 0.99. What is the ratio of the Primary completion rate (% of total enrollments) in Tunisia in 2007 to that in 2008?
Your answer should be very brief. 1.1. What is the ratio of the Primary completion rate (% of total enrollments) in Zambia in 2007 to that in 2008?
Provide a succinct answer. 0.97. What is the ratio of the Primary completion rate (% of total enrollments) of Finland in 2007 to that in 2009?
Ensure brevity in your answer.  1. What is the ratio of the Primary completion rate (% of total enrollments) in Guyana in 2007 to that in 2009?
Offer a terse response. 1.01. What is the ratio of the Primary completion rate (% of total enrollments) of Tunisia in 2007 to that in 2009?
Your response must be concise. 1.15. What is the ratio of the Primary completion rate (% of total enrollments) in Zambia in 2007 to that in 2009?
Make the answer very short. 1.04. What is the ratio of the Primary completion rate (% of total enrollments) of Guyana in 2007 to that in 2010?
Offer a very short reply. 1.1. What is the ratio of the Primary completion rate (% of total enrollments) in Tunisia in 2007 to that in 2010?
Your answer should be compact. 1. What is the ratio of the Primary completion rate (% of total enrollments) of Zambia in 2007 to that in 2010?
Provide a short and direct response. 1.01. What is the ratio of the Primary completion rate (% of total enrollments) in Finland in 2008 to that in 2009?
Provide a succinct answer. 1.02. What is the ratio of the Primary completion rate (% of total enrollments) of Guyana in 2008 to that in 2009?
Give a very brief answer. 1. What is the ratio of the Primary completion rate (% of total enrollments) in Tunisia in 2008 to that in 2009?
Make the answer very short. 1.04. What is the ratio of the Primary completion rate (% of total enrollments) in Zambia in 2008 to that in 2009?
Make the answer very short. 1.08. What is the ratio of the Primary completion rate (% of total enrollments) of Finland in 2008 to that in 2010?
Give a very brief answer. 1.02. What is the ratio of the Primary completion rate (% of total enrollments) in Guyana in 2008 to that in 2010?
Make the answer very short. 1.09. What is the ratio of the Primary completion rate (% of total enrollments) in Tunisia in 2008 to that in 2010?
Your answer should be compact. 0.91. What is the ratio of the Primary completion rate (% of total enrollments) of Zambia in 2008 to that in 2010?
Your response must be concise. 1.05. What is the ratio of the Primary completion rate (% of total enrollments) of Guyana in 2009 to that in 2010?
Your answer should be very brief. 1.09. What is the ratio of the Primary completion rate (% of total enrollments) in Tunisia in 2009 to that in 2010?
Give a very brief answer. 0.87. What is the ratio of the Primary completion rate (% of total enrollments) in Zambia in 2009 to that in 2010?
Make the answer very short. 0.97. What is the difference between the highest and the second highest Primary completion rate (% of total enrollments) of Finland?
Offer a very short reply. 1.71. What is the difference between the highest and the second highest Primary completion rate (% of total enrollments) of Guyana?
Give a very brief answer. 0.16. What is the difference between the highest and the second highest Primary completion rate (% of total enrollments) of Tunisia?
Offer a terse response. 0.29. What is the difference between the highest and the second highest Primary completion rate (% of total enrollments) of Zambia?
Ensure brevity in your answer.  1.05. What is the difference between the highest and the lowest Primary completion rate (% of total enrollments) in Finland?
Make the answer very short. 4.88. What is the difference between the highest and the lowest Primary completion rate (% of total enrollments) of Guyana?
Ensure brevity in your answer.  14.32. What is the difference between the highest and the lowest Primary completion rate (% of total enrollments) in Tunisia?
Make the answer very short. 13.24. What is the difference between the highest and the lowest Primary completion rate (% of total enrollments) in Zambia?
Give a very brief answer. 32.63. 